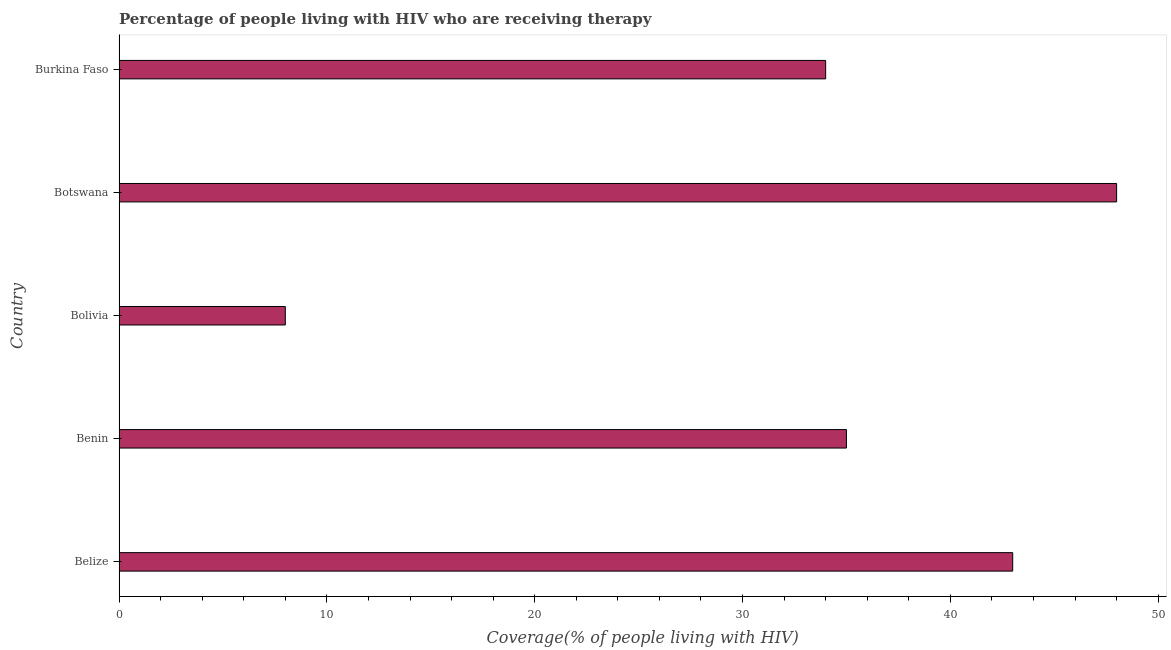Does the graph contain any zero values?
Provide a succinct answer. No. What is the title of the graph?
Provide a succinct answer. Percentage of people living with HIV who are receiving therapy. What is the label or title of the X-axis?
Provide a short and direct response. Coverage(% of people living with HIV). What is the label or title of the Y-axis?
Provide a short and direct response. Country. What is the antiretroviral therapy coverage in Bolivia?
Provide a short and direct response. 8. In which country was the antiretroviral therapy coverage maximum?
Your response must be concise. Botswana. What is the sum of the antiretroviral therapy coverage?
Offer a terse response. 168. What is the average antiretroviral therapy coverage per country?
Offer a very short reply. 33.6. What is the median antiretroviral therapy coverage?
Ensure brevity in your answer.  35. In how many countries, is the antiretroviral therapy coverage greater than 46 %?
Your answer should be very brief. 1. What is the ratio of the antiretroviral therapy coverage in Botswana to that in Burkina Faso?
Offer a terse response. 1.41. Is the antiretroviral therapy coverage in Bolivia less than that in Botswana?
Provide a succinct answer. Yes. Is the difference between the antiretroviral therapy coverage in Belize and Bolivia greater than the difference between any two countries?
Keep it short and to the point. No. Is the sum of the antiretroviral therapy coverage in Benin and Burkina Faso greater than the maximum antiretroviral therapy coverage across all countries?
Give a very brief answer. Yes. In how many countries, is the antiretroviral therapy coverage greater than the average antiretroviral therapy coverage taken over all countries?
Give a very brief answer. 4. Are all the bars in the graph horizontal?
Your answer should be very brief. Yes. How many countries are there in the graph?
Your answer should be very brief. 5. What is the difference between two consecutive major ticks on the X-axis?
Offer a terse response. 10. What is the Coverage(% of people living with HIV) in Bolivia?
Offer a very short reply. 8. What is the Coverage(% of people living with HIV) of Burkina Faso?
Offer a terse response. 34. What is the difference between the Coverage(% of people living with HIV) in Belize and Benin?
Provide a succinct answer. 8. What is the difference between the Coverage(% of people living with HIV) in Belize and Bolivia?
Provide a short and direct response. 35. What is the difference between the Coverage(% of people living with HIV) in Benin and Botswana?
Provide a short and direct response. -13. What is the difference between the Coverage(% of people living with HIV) in Benin and Burkina Faso?
Provide a short and direct response. 1. What is the difference between the Coverage(% of people living with HIV) in Bolivia and Burkina Faso?
Your answer should be very brief. -26. What is the ratio of the Coverage(% of people living with HIV) in Belize to that in Benin?
Offer a very short reply. 1.23. What is the ratio of the Coverage(% of people living with HIV) in Belize to that in Bolivia?
Give a very brief answer. 5.38. What is the ratio of the Coverage(% of people living with HIV) in Belize to that in Botswana?
Keep it short and to the point. 0.9. What is the ratio of the Coverage(% of people living with HIV) in Belize to that in Burkina Faso?
Provide a short and direct response. 1.26. What is the ratio of the Coverage(% of people living with HIV) in Benin to that in Bolivia?
Make the answer very short. 4.38. What is the ratio of the Coverage(% of people living with HIV) in Benin to that in Botswana?
Keep it short and to the point. 0.73. What is the ratio of the Coverage(% of people living with HIV) in Bolivia to that in Botswana?
Ensure brevity in your answer.  0.17. What is the ratio of the Coverage(% of people living with HIV) in Bolivia to that in Burkina Faso?
Make the answer very short. 0.23. What is the ratio of the Coverage(% of people living with HIV) in Botswana to that in Burkina Faso?
Your answer should be very brief. 1.41. 